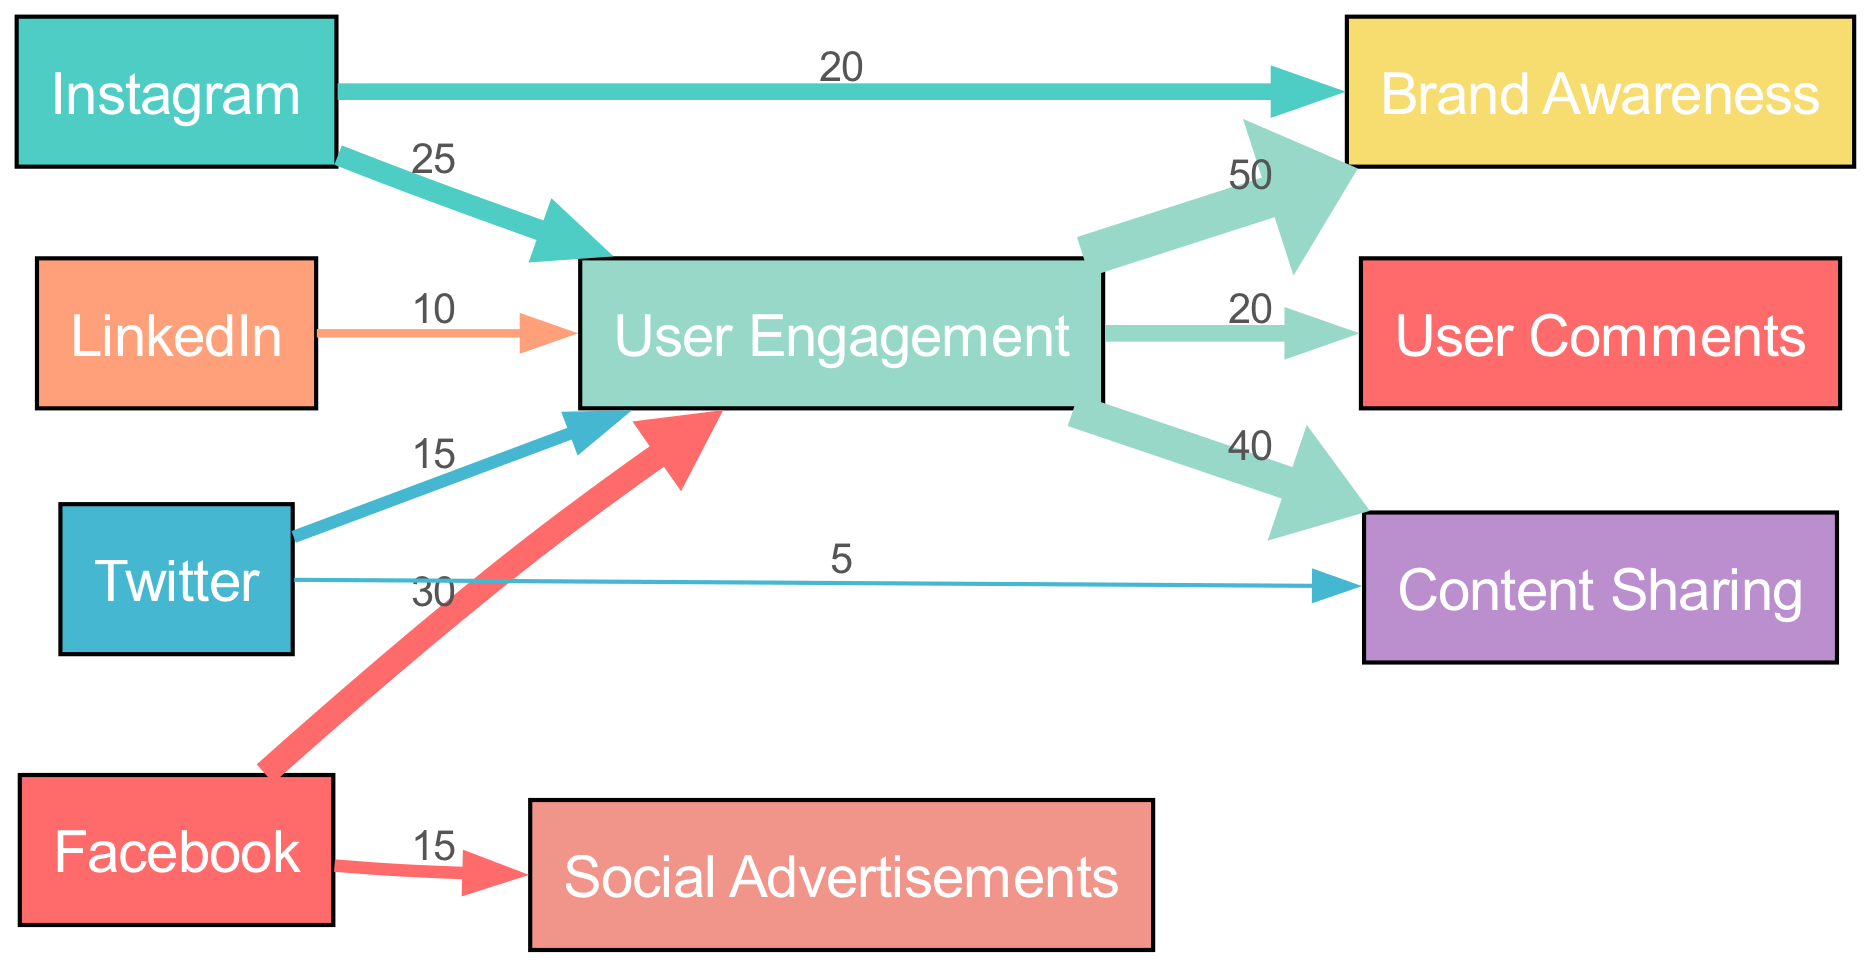What is the total number of nodes in the diagram? The diagram includes both the platforms (Facebook, Instagram, Twitter, LinkedIn) and the user engagement elements (User Engagement, Brand Awareness, Content Sharing, Social Advertisements, User Comments). Counting these, we find there are 9 nodes in total.
Answer: 9 Which platform has the highest value of user engagement? By examining the flow from each platform to User Engagement, the values are: Facebook with 30, Instagram with 25, Twitter with 15, and LinkedIn with 10. Facebook has the highest value of 30.
Answer: Facebook What is the value of user engagement leading to brand awareness? The diagram indicates that the flow from User Engagement to Brand Awareness has a value of 50. This represents the total user engagement that contributes to brand awareness.
Answer: 50 How many interactions flow from Instagram to Brand Awareness? The diagram shows a direct flow from Instagram to Brand Awareness with a value of 20. This indicates the number of interactions from Instagram that contribute specifically to brand awareness.
Answer: 20 What percentage of user engagement comes from Facebook compared to the total user engagement? The total user engagement is 80 (30 from Facebook, 25 from Instagram, 15 from Twitter, and 10 from LinkedIn). Facebook contributes 30. Calculating the percentage, (30/80)*100 = 37.5%.
Answer: 37.5% Which interaction type has the least value in terms of contributing to user engagement from Twitter? Looking at the flows from Twitter, it has a value of 15 to User Engagement and a value of 5 to Content Sharing. The latter is the least value coming specifically from Twitter.
Answer: Content Sharing What is the connection strength between User Engagement and Content Sharing? The link from User Engagement to Content Sharing has a value of 40, indicating a strong connection based on the flow represented in the diagram.
Answer: 40 Which node has the highest number of outgoing connections? User Engagement serves as a central hub with outgoing connections to Brand Awareness, Content Sharing, and User Comments. Thus, it has 3 outgoing connections in total, which is the highest.
Answer: User Engagement Is there any flow from LinkedIn to Brand Awareness? Analyzing the connections, there is no direct flow from LinkedIn to Brand Awareness indicated in the diagram. Thus, the answer is no.
Answer: No 